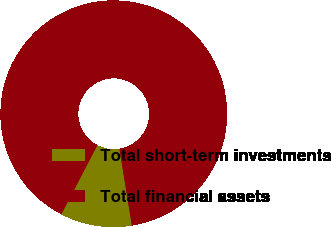Convert chart. <chart><loc_0><loc_0><loc_500><loc_500><pie_chart><fcel>Total short-term investments<fcel>Total financial assets<nl><fcel>10.2%<fcel>89.8%<nl></chart> 